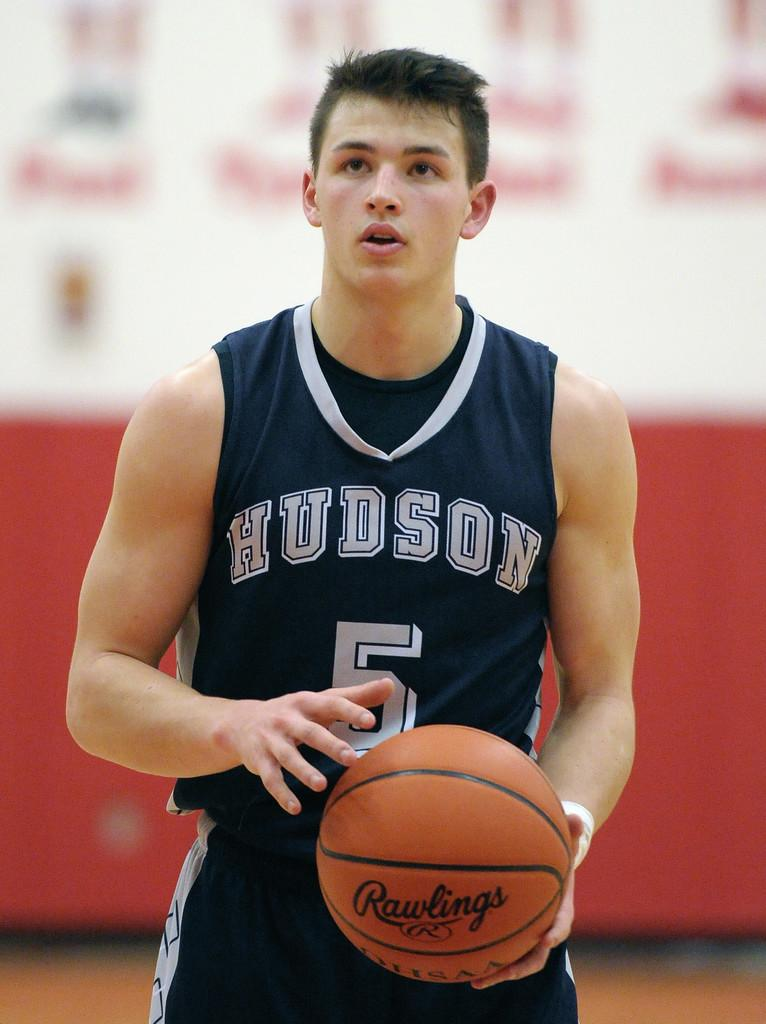<image>
Relay a brief, clear account of the picture shown. a basketball player with the word Hudson on their jersey 